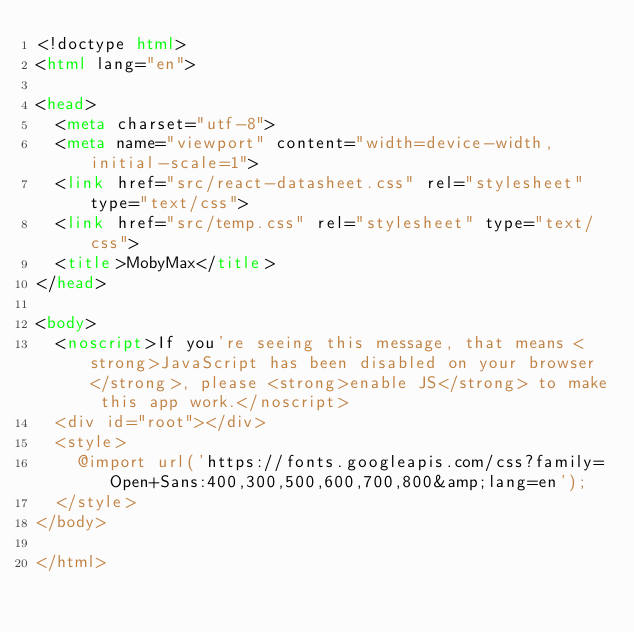Convert code to text. <code><loc_0><loc_0><loc_500><loc_500><_HTML_><!doctype html>
<html lang="en">

<head>
  <meta charset="utf-8">
  <meta name="viewport" content="width=device-width, initial-scale=1">
  <link href="src/react-datasheet.css" rel="stylesheet" type="text/css">
  <link href="src/temp.css" rel="stylesheet" type="text/css">
  <title>MobyMax</title>
</head>

<body>
  <noscript>If you're seeing this message, that means <strong>JavaScript has been disabled on your browser</strong>, please <strong>enable JS</strong> to make this app work.</noscript>
  <div id="root"></div>
  <style>
    @import url('https://fonts.googleapis.com/css?family=Open+Sans:400,300,500,600,700,800&amp;lang=en');
  </style>
</body>

</html></code> 